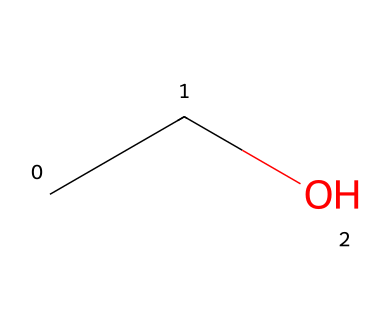What is the name of this chemical? The chemical structure corresponds to the molecular formula C2H6O, which is recognized as ethanol, commonly known as alcohol.
Answer: ethanol How many carbon atoms are in this molecule? By examining the structure, there are two carbon atoms present in the molecular formula C2H6O.
Answer: 2 How many hydrogen atoms does this chemical contain? From the molecular formula C2H6O, it can be observed that there are six hydrogen atoms.
Answer: 6 Is this chemical soluble in water? Ethanol is known to be highly soluble in water due to its molecular structure that allows for hydrogen bonding with water molecules.
Answer: yes What type of bonding is predominant in this molecule? The molecule primarily exhibits covalent bonding between carbon, hydrogen, and oxygen atoms, resulting from the sharing of electrons.
Answer: covalent What functional group is present in this structure? The presence of the -OH group in the structure indicates that this molecule contains a hydroxyl functional group, characteristic of alcohols.
Answer: hydroxyl Is this molecule a gas at room temperature? Ethanol is a liquid at room temperature; it does not fit the characteristics of a gas based on its boiling point and molecular weight.
Answer: no 